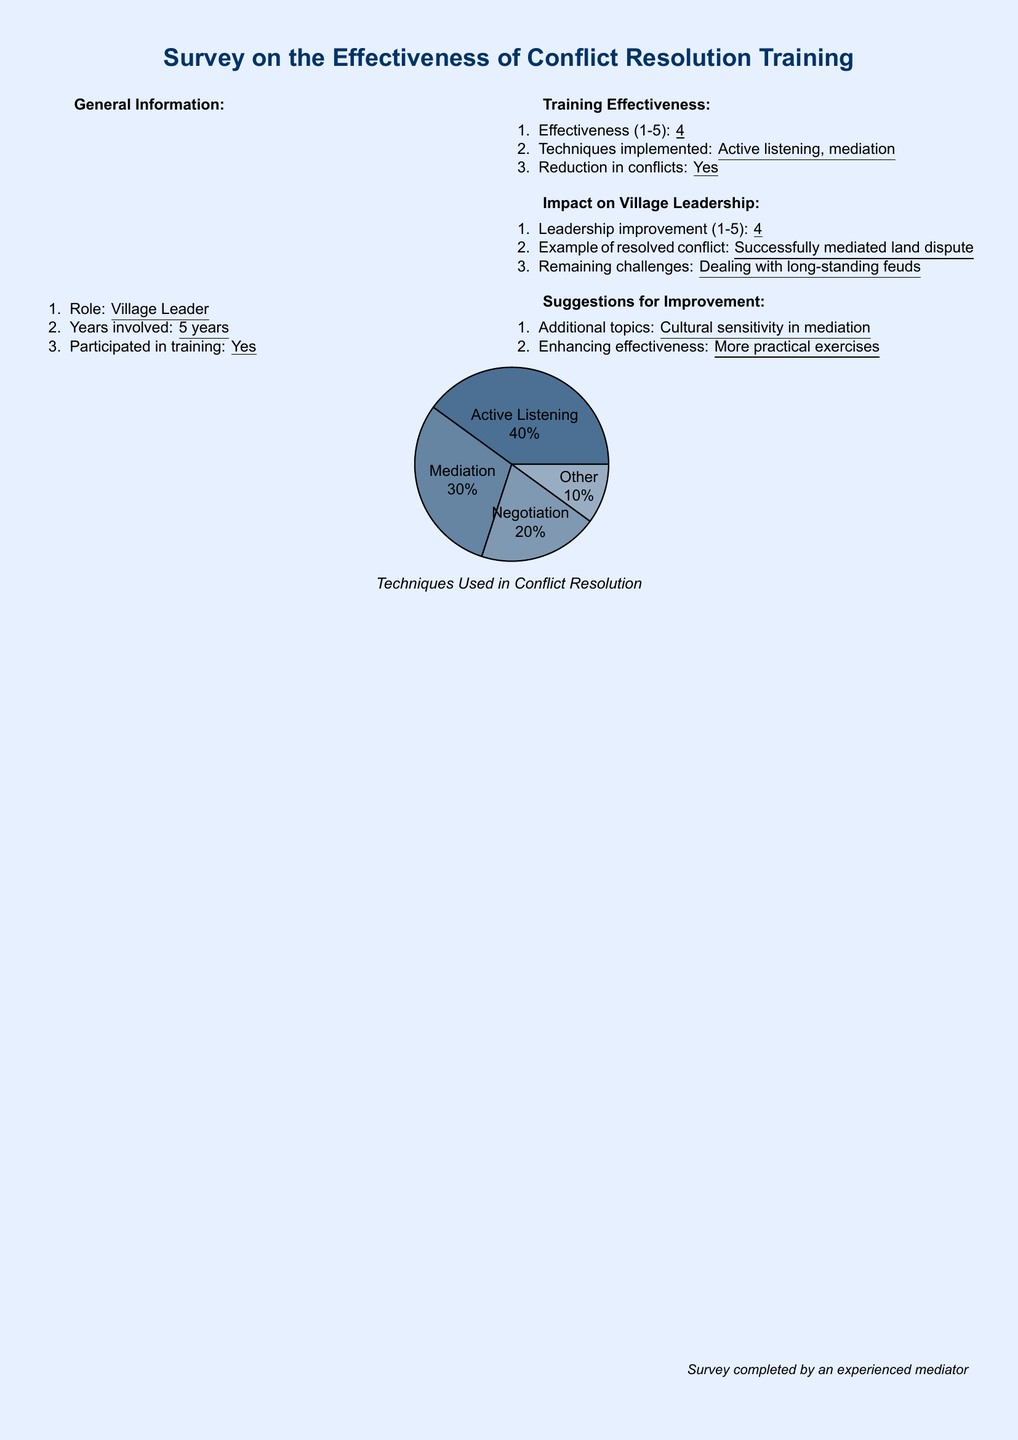What is the role of the respondent? The role of the respondent is indicated in the General Information section of the document.
Answer: Village Leader How many years has the respondent been involved? This information is found under General Information and specifies the duration of involvement.
Answer: 5 years What was the effectiveness rating given for the training? The effectiveness rating is provided in the Training Effectiveness section of the document.
Answer: 4 What technique was implemented for conflict resolution? Techniques implemented are listed in the Training Effectiveness section.
Answer: Active listening What example of resolved conflict is provided? An example is highlighted in the Impact on Village Leadership section.
Answer: Successfully mediated land dispute What remaining challenge is noted? The challenge is found in the Impact on Village Leadership section.
Answer: Dealing with long-standing feuds Which topic is suggested for additional training? This suggestion is made in the Suggestions for Improvement section.
Answer: Cultural sensitivity in mediation What percentage of techniques used was for negotiation? The percentage is illustrated in the pie chart of techniques used in the document.
Answer: 20 How many techniques are mentioned in the pie chart? The pie chart details the techniques used, summing them up.
Answer: 4 